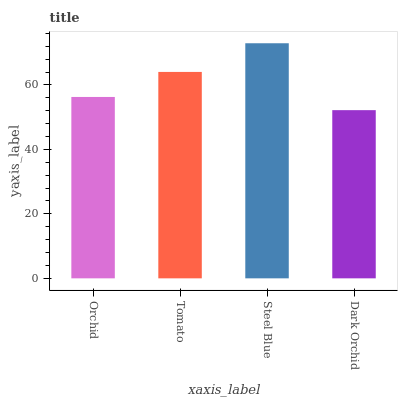Is Dark Orchid the minimum?
Answer yes or no. Yes. Is Steel Blue the maximum?
Answer yes or no. Yes. Is Tomato the minimum?
Answer yes or no. No. Is Tomato the maximum?
Answer yes or no. No. Is Tomato greater than Orchid?
Answer yes or no. Yes. Is Orchid less than Tomato?
Answer yes or no. Yes. Is Orchid greater than Tomato?
Answer yes or no. No. Is Tomato less than Orchid?
Answer yes or no. No. Is Tomato the high median?
Answer yes or no. Yes. Is Orchid the low median?
Answer yes or no. Yes. Is Dark Orchid the high median?
Answer yes or no. No. Is Dark Orchid the low median?
Answer yes or no. No. 